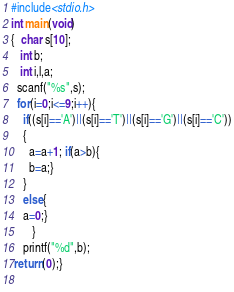Convert code to text. <code><loc_0><loc_0><loc_500><loc_500><_C_>#include<stdio.h>
int main(void)
{  char s[10];
   int b;
   int i,l,a;
  scanf("%s",s);
  for(i=0;i<=9;i++){
    if((s[i]=='A')||(s[i]=='T')||(s[i]=='G')||(s[i]=='C'))
    {
      a=a+1; if(a>b){
      b=a;}
    }       
    else{
    a=0;}
       }
    printf("%d",b);
 return(0);}
  </code> 